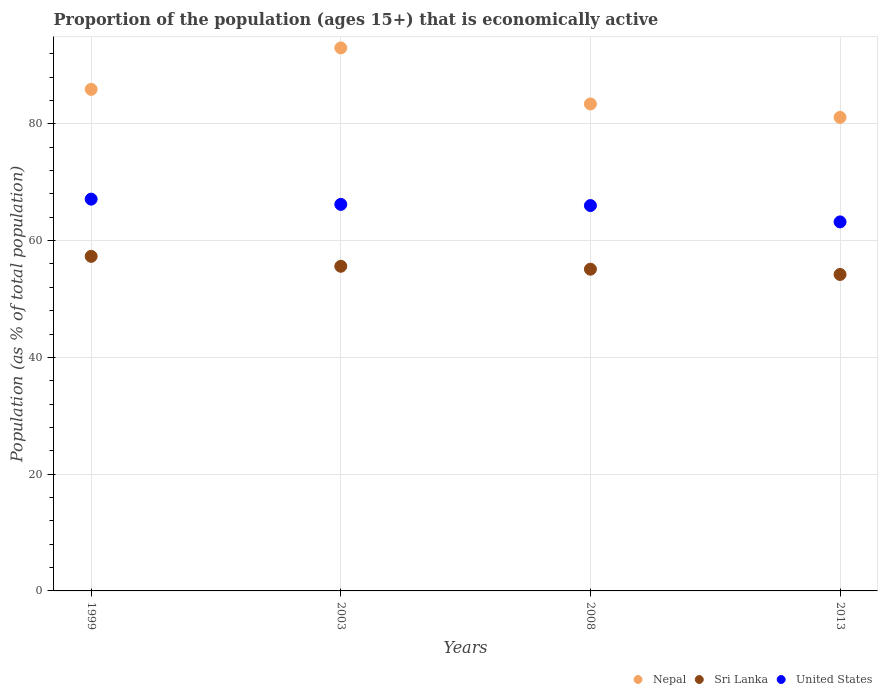What is the proportion of the population that is economically active in Sri Lanka in 2008?
Offer a terse response. 55.1. Across all years, what is the maximum proportion of the population that is economically active in United States?
Offer a very short reply. 67.1. Across all years, what is the minimum proportion of the population that is economically active in Sri Lanka?
Offer a very short reply. 54.2. In which year was the proportion of the population that is economically active in Sri Lanka maximum?
Your answer should be compact. 1999. In which year was the proportion of the population that is economically active in Nepal minimum?
Give a very brief answer. 2013. What is the total proportion of the population that is economically active in Sri Lanka in the graph?
Keep it short and to the point. 222.2. What is the difference between the proportion of the population that is economically active in United States in 1999 and that in 2008?
Offer a terse response. 1.1. What is the difference between the proportion of the population that is economically active in Sri Lanka in 2003 and the proportion of the population that is economically active in United States in 1999?
Ensure brevity in your answer.  -11.5. What is the average proportion of the population that is economically active in Sri Lanka per year?
Offer a very short reply. 55.55. In the year 2008, what is the difference between the proportion of the population that is economically active in Sri Lanka and proportion of the population that is economically active in United States?
Your answer should be very brief. -10.9. What is the ratio of the proportion of the population that is economically active in Nepal in 2008 to that in 2013?
Provide a short and direct response. 1.03. Is the proportion of the population that is economically active in Sri Lanka in 1999 less than that in 2008?
Offer a very short reply. No. Is the difference between the proportion of the population that is economically active in Sri Lanka in 1999 and 2003 greater than the difference between the proportion of the population that is economically active in United States in 1999 and 2003?
Make the answer very short. Yes. What is the difference between the highest and the second highest proportion of the population that is economically active in United States?
Your response must be concise. 0.9. What is the difference between the highest and the lowest proportion of the population that is economically active in United States?
Ensure brevity in your answer.  3.9. Is the sum of the proportion of the population that is economically active in Nepal in 1999 and 2013 greater than the maximum proportion of the population that is economically active in Sri Lanka across all years?
Make the answer very short. Yes. Is the proportion of the population that is economically active in Nepal strictly greater than the proportion of the population that is economically active in United States over the years?
Make the answer very short. Yes. What is the difference between two consecutive major ticks on the Y-axis?
Ensure brevity in your answer.  20. How many legend labels are there?
Give a very brief answer. 3. What is the title of the graph?
Your answer should be compact. Proportion of the population (ages 15+) that is economically active. What is the label or title of the Y-axis?
Offer a very short reply. Population (as % of total population). What is the Population (as % of total population) in Nepal in 1999?
Your answer should be compact. 85.9. What is the Population (as % of total population) in Sri Lanka in 1999?
Your answer should be compact. 57.3. What is the Population (as % of total population) in United States in 1999?
Ensure brevity in your answer.  67.1. What is the Population (as % of total population) in Nepal in 2003?
Provide a succinct answer. 93. What is the Population (as % of total population) of Sri Lanka in 2003?
Provide a succinct answer. 55.6. What is the Population (as % of total population) in United States in 2003?
Offer a terse response. 66.2. What is the Population (as % of total population) of Nepal in 2008?
Ensure brevity in your answer.  83.4. What is the Population (as % of total population) of Sri Lanka in 2008?
Keep it short and to the point. 55.1. What is the Population (as % of total population) in Nepal in 2013?
Offer a very short reply. 81.1. What is the Population (as % of total population) in Sri Lanka in 2013?
Your answer should be very brief. 54.2. What is the Population (as % of total population) in United States in 2013?
Offer a very short reply. 63.2. Across all years, what is the maximum Population (as % of total population) in Nepal?
Keep it short and to the point. 93. Across all years, what is the maximum Population (as % of total population) of Sri Lanka?
Offer a terse response. 57.3. Across all years, what is the maximum Population (as % of total population) of United States?
Provide a short and direct response. 67.1. Across all years, what is the minimum Population (as % of total population) in Nepal?
Offer a terse response. 81.1. Across all years, what is the minimum Population (as % of total population) of Sri Lanka?
Provide a succinct answer. 54.2. Across all years, what is the minimum Population (as % of total population) of United States?
Provide a succinct answer. 63.2. What is the total Population (as % of total population) of Nepal in the graph?
Keep it short and to the point. 343.4. What is the total Population (as % of total population) in Sri Lanka in the graph?
Offer a terse response. 222.2. What is the total Population (as % of total population) in United States in the graph?
Offer a very short reply. 262.5. What is the difference between the Population (as % of total population) of Sri Lanka in 1999 and that in 2003?
Provide a short and direct response. 1.7. What is the difference between the Population (as % of total population) of United States in 1999 and that in 2013?
Make the answer very short. 3.9. What is the difference between the Population (as % of total population) in Nepal in 2003 and that in 2008?
Your response must be concise. 9.6. What is the difference between the Population (as % of total population) in Sri Lanka in 2003 and that in 2013?
Offer a terse response. 1.4. What is the difference between the Population (as % of total population) in Sri Lanka in 2008 and that in 2013?
Your answer should be very brief. 0.9. What is the difference between the Population (as % of total population) in Nepal in 1999 and the Population (as % of total population) in Sri Lanka in 2003?
Give a very brief answer. 30.3. What is the difference between the Population (as % of total population) in Nepal in 1999 and the Population (as % of total population) in United States in 2003?
Offer a very short reply. 19.7. What is the difference between the Population (as % of total population) in Sri Lanka in 1999 and the Population (as % of total population) in United States in 2003?
Ensure brevity in your answer.  -8.9. What is the difference between the Population (as % of total population) of Nepal in 1999 and the Population (as % of total population) of Sri Lanka in 2008?
Provide a short and direct response. 30.8. What is the difference between the Population (as % of total population) in Nepal in 1999 and the Population (as % of total population) in United States in 2008?
Keep it short and to the point. 19.9. What is the difference between the Population (as % of total population) of Sri Lanka in 1999 and the Population (as % of total population) of United States in 2008?
Your response must be concise. -8.7. What is the difference between the Population (as % of total population) in Nepal in 1999 and the Population (as % of total population) in Sri Lanka in 2013?
Ensure brevity in your answer.  31.7. What is the difference between the Population (as % of total population) in Nepal in 1999 and the Population (as % of total population) in United States in 2013?
Provide a succinct answer. 22.7. What is the difference between the Population (as % of total population) in Nepal in 2003 and the Population (as % of total population) in Sri Lanka in 2008?
Your answer should be compact. 37.9. What is the difference between the Population (as % of total population) of Sri Lanka in 2003 and the Population (as % of total population) of United States in 2008?
Keep it short and to the point. -10.4. What is the difference between the Population (as % of total population) of Nepal in 2003 and the Population (as % of total population) of Sri Lanka in 2013?
Give a very brief answer. 38.8. What is the difference between the Population (as % of total population) in Nepal in 2003 and the Population (as % of total population) in United States in 2013?
Provide a short and direct response. 29.8. What is the difference between the Population (as % of total population) in Nepal in 2008 and the Population (as % of total population) in Sri Lanka in 2013?
Your answer should be very brief. 29.2. What is the difference between the Population (as % of total population) in Nepal in 2008 and the Population (as % of total population) in United States in 2013?
Make the answer very short. 20.2. What is the difference between the Population (as % of total population) in Sri Lanka in 2008 and the Population (as % of total population) in United States in 2013?
Your answer should be very brief. -8.1. What is the average Population (as % of total population) in Nepal per year?
Ensure brevity in your answer.  85.85. What is the average Population (as % of total population) in Sri Lanka per year?
Offer a terse response. 55.55. What is the average Population (as % of total population) of United States per year?
Offer a terse response. 65.62. In the year 1999, what is the difference between the Population (as % of total population) of Nepal and Population (as % of total population) of Sri Lanka?
Your answer should be compact. 28.6. In the year 1999, what is the difference between the Population (as % of total population) in Nepal and Population (as % of total population) in United States?
Offer a terse response. 18.8. In the year 2003, what is the difference between the Population (as % of total population) in Nepal and Population (as % of total population) in Sri Lanka?
Provide a short and direct response. 37.4. In the year 2003, what is the difference between the Population (as % of total population) of Nepal and Population (as % of total population) of United States?
Keep it short and to the point. 26.8. In the year 2008, what is the difference between the Population (as % of total population) of Nepal and Population (as % of total population) of Sri Lanka?
Make the answer very short. 28.3. In the year 2008, what is the difference between the Population (as % of total population) in Sri Lanka and Population (as % of total population) in United States?
Keep it short and to the point. -10.9. In the year 2013, what is the difference between the Population (as % of total population) in Nepal and Population (as % of total population) in Sri Lanka?
Your answer should be very brief. 26.9. What is the ratio of the Population (as % of total population) of Nepal in 1999 to that in 2003?
Ensure brevity in your answer.  0.92. What is the ratio of the Population (as % of total population) in Sri Lanka in 1999 to that in 2003?
Ensure brevity in your answer.  1.03. What is the ratio of the Population (as % of total population) in United States in 1999 to that in 2003?
Offer a very short reply. 1.01. What is the ratio of the Population (as % of total population) in Nepal in 1999 to that in 2008?
Offer a very short reply. 1.03. What is the ratio of the Population (as % of total population) in Sri Lanka in 1999 to that in 2008?
Give a very brief answer. 1.04. What is the ratio of the Population (as % of total population) in United States in 1999 to that in 2008?
Ensure brevity in your answer.  1.02. What is the ratio of the Population (as % of total population) of Nepal in 1999 to that in 2013?
Your response must be concise. 1.06. What is the ratio of the Population (as % of total population) of Sri Lanka in 1999 to that in 2013?
Offer a terse response. 1.06. What is the ratio of the Population (as % of total population) of United States in 1999 to that in 2013?
Offer a terse response. 1.06. What is the ratio of the Population (as % of total population) in Nepal in 2003 to that in 2008?
Provide a succinct answer. 1.12. What is the ratio of the Population (as % of total population) in Sri Lanka in 2003 to that in 2008?
Provide a succinct answer. 1.01. What is the ratio of the Population (as % of total population) in United States in 2003 to that in 2008?
Offer a terse response. 1. What is the ratio of the Population (as % of total population) of Nepal in 2003 to that in 2013?
Keep it short and to the point. 1.15. What is the ratio of the Population (as % of total population) of Sri Lanka in 2003 to that in 2013?
Your answer should be compact. 1.03. What is the ratio of the Population (as % of total population) of United States in 2003 to that in 2013?
Your answer should be very brief. 1.05. What is the ratio of the Population (as % of total population) of Nepal in 2008 to that in 2013?
Ensure brevity in your answer.  1.03. What is the ratio of the Population (as % of total population) of Sri Lanka in 2008 to that in 2013?
Offer a terse response. 1.02. What is the ratio of the Population (as % of total population) of United States in 2008 to that in 2013?
Your response must be concise. 1.04. What is the difference between the highest and the second highest Population (as % of total population) of Sri Lanka?
Your answer should be compact. 1.7. What is the difference between the highest and the lowest Population (as % of total population) in Sri Lanka?
Your response must be concise. 3.1. What is the difference between the highest and the lowest Population (as % of total population) of United States?
Provide a short and direct response. 3.9. 